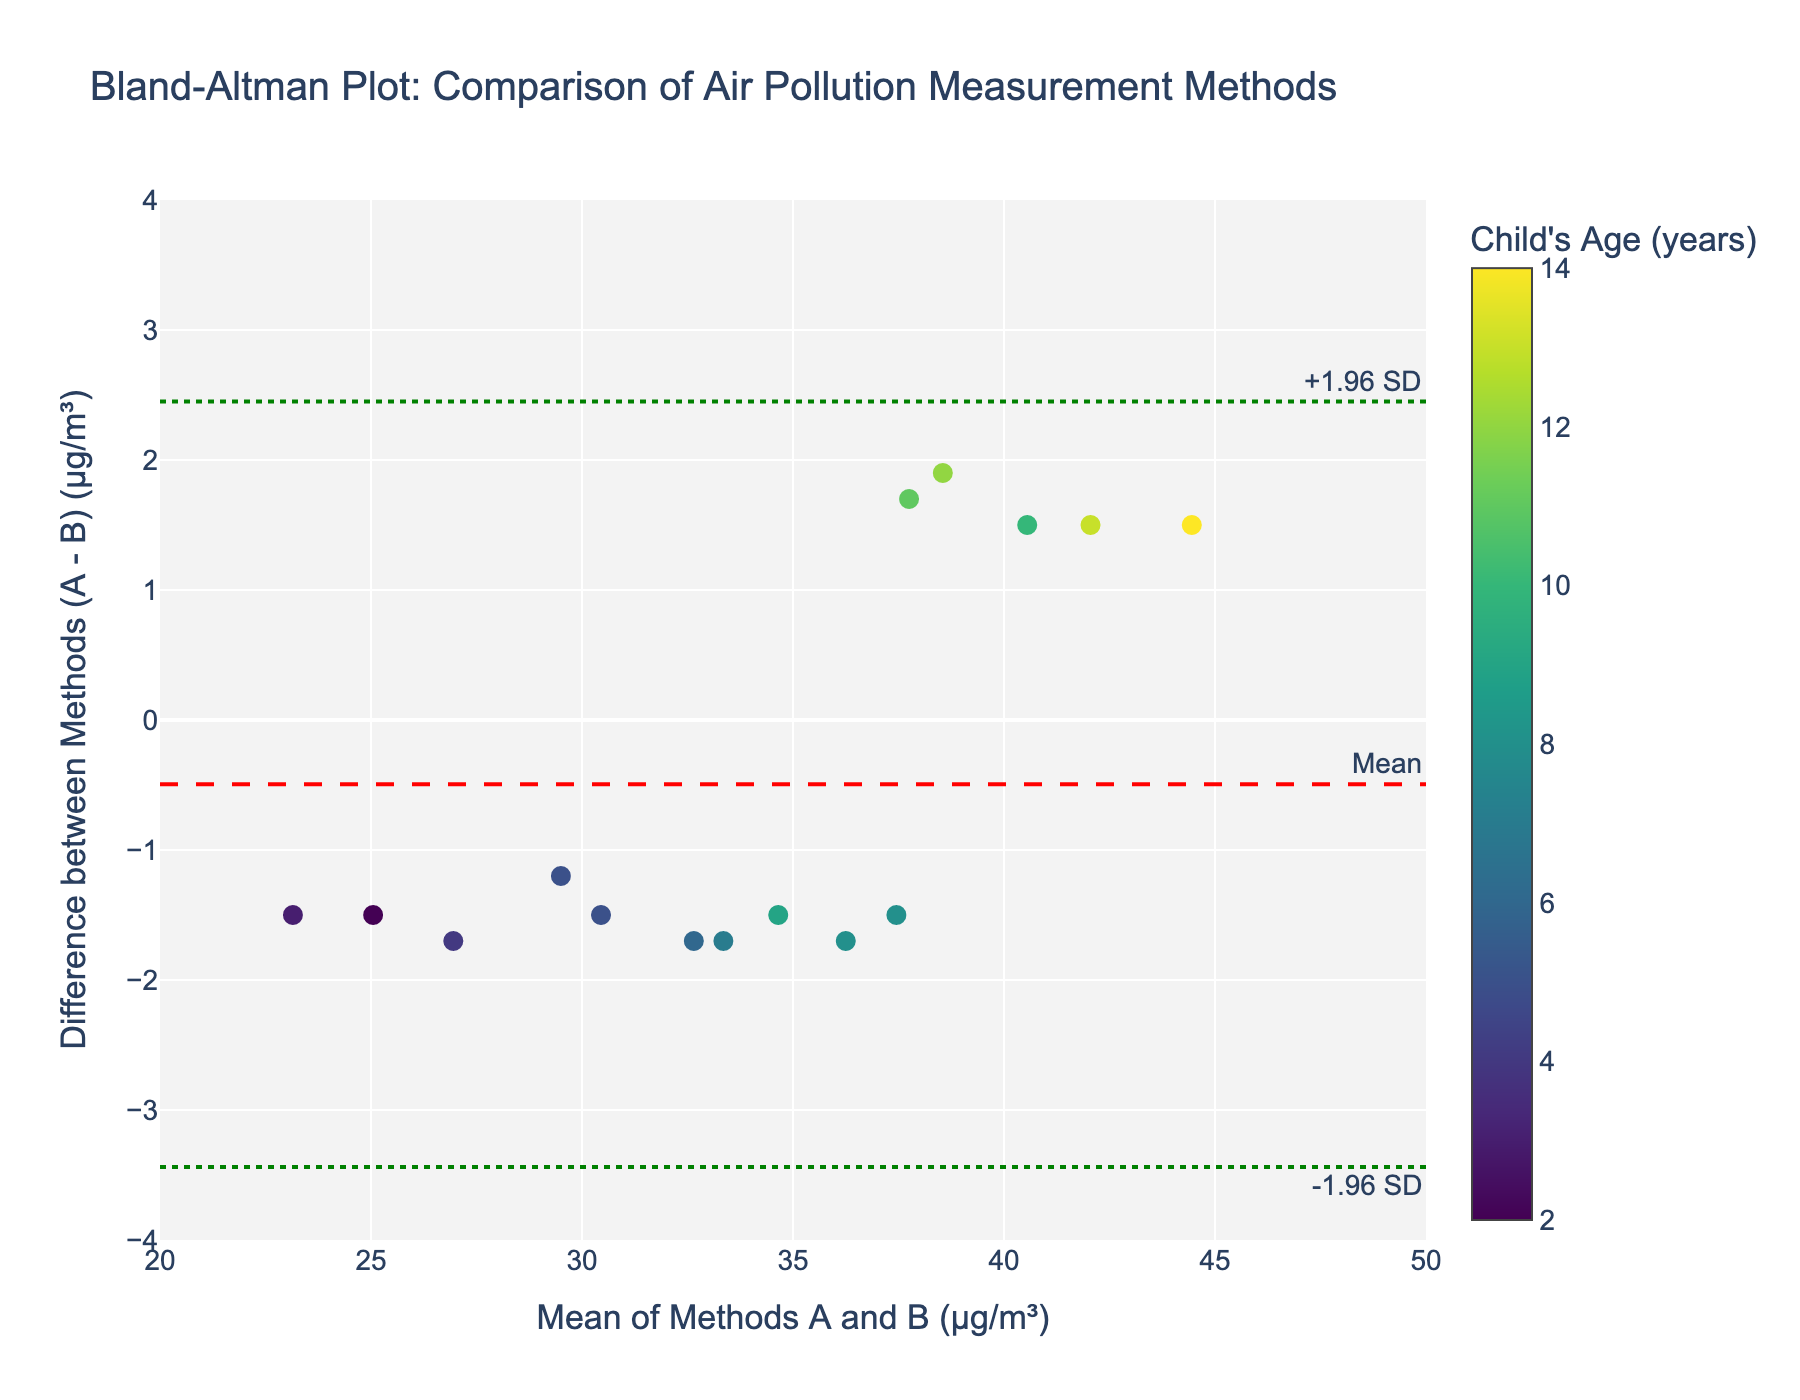How many data points are plotted in the figure? Count the number of markers (circles) in the scatter plot. Each marker represents a data point.
Answer: 15 What is the title of the figure? Read the title text at the top center of the plot.
Answer: Bland-Altman Plot: Comparison of Air Pollution Measurement Methods What is the mean difference between Methods A and B? Look for the red dashed line labeled "Mean" on the y-axis, indicating the mean difference.
Answer: Approximately 0.93 µg/m³ What are the horizontal axis and vertical axis labeled as? Read the labels next to the x and y-axes.
Answer: X-axis: Mean of Methods A and B (µg/m³), Y-axis: Difference between Methods (A - B) (µg/m³) What are the upper and lower limits of agreement (LoA)? Find the green dotted lines on the y-axis. They are labeled with "+1.96 SD" for the upper LoA and "-1.96 SD" for the lower LoA.
Answer: Upper LoA: Approximately 3.87 µg/m³, Lower LoA: Approximately -2.01 µg/m³ Which child's age corresponds to the highest mean value between Methods A and B in the plot? Identify the data point with the highest x-value on the plot and note the age from the attached color bar or hover text.
Answer: 14 years What is the difference in µg/m³ between Methods A and B for a child of age 10? Hover over the data point for age 10 and read the y-value (difference).
Answer: Approximately 1.5 µg/m³ Is there any child for which Methods A and B gave nearly identical readings (difference close to zero)? Look for data points near the zero line on the y-axis. Hover over them to identify their age.
Answer: Yes, child of age 12 Does the difference between the methods appear to increase or decrease with the mean value? Observe the scatter plot's trend. Check if the differences are more spread out for higher mean values.
Answer: The difference appears to be roughly consistent regardless of mean value, with no clear increasing or decreasing trend What does the color scale in the plot represent? Read the title of the color bar located beside the plot.
Answer: Child's Age (years) 